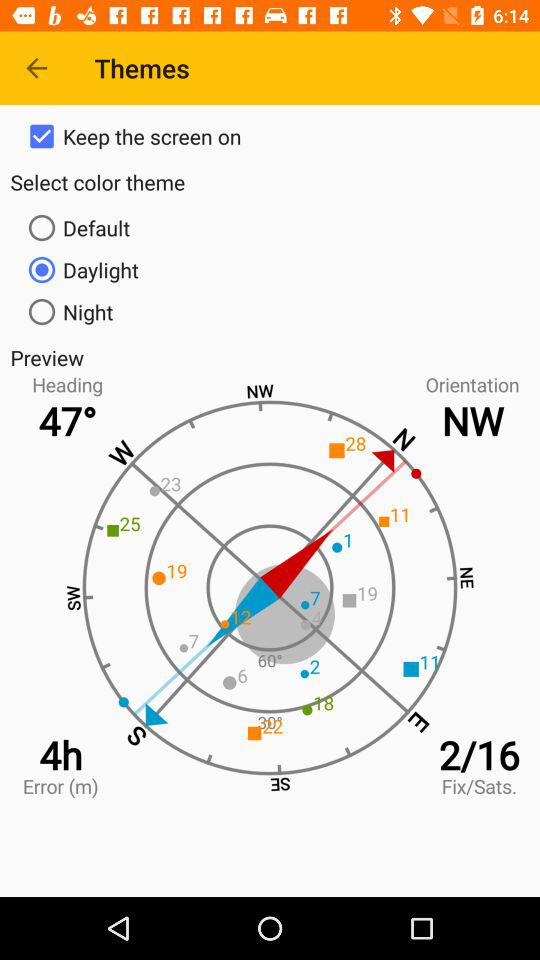What is the status of "Keep the screen on"? The status is "on". 